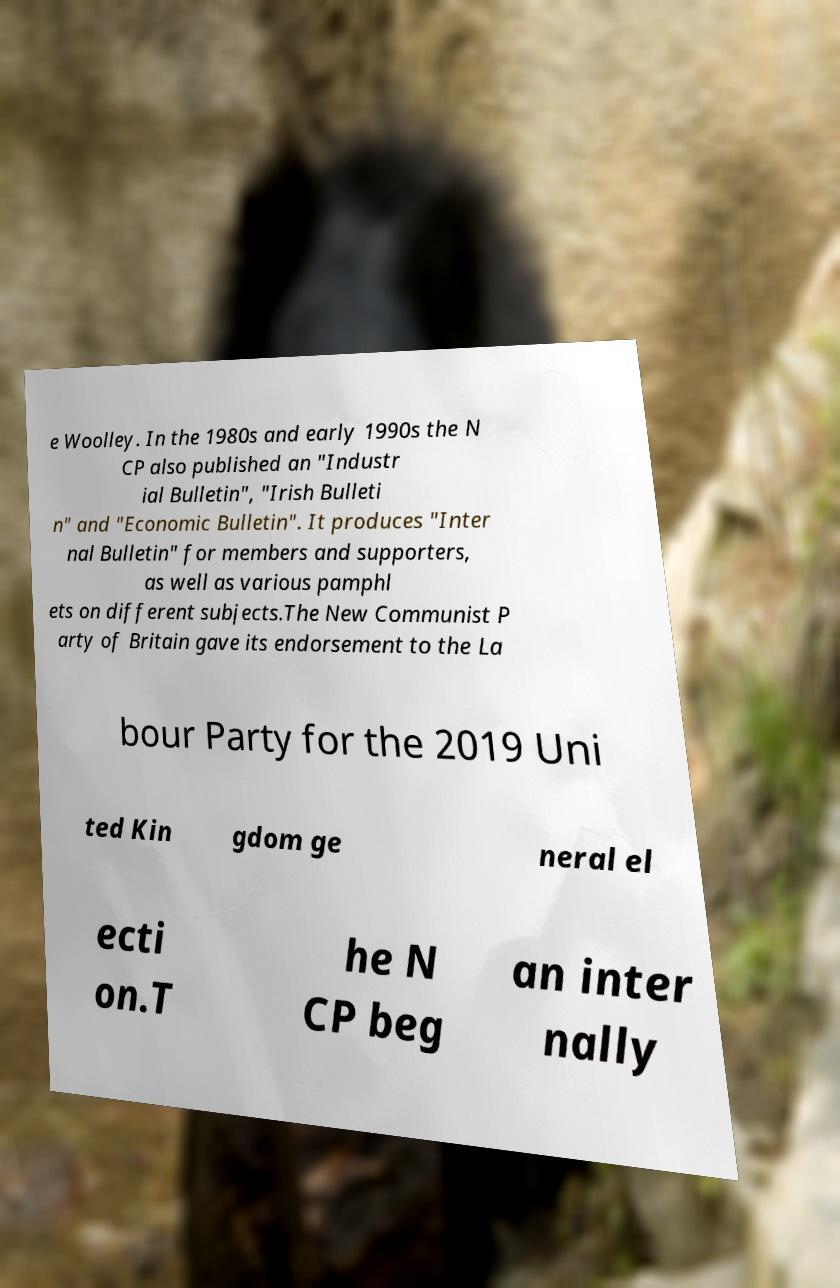There's text embedded in this image that I need extracted. Can you transcribe it verbatim? e Woolley. In the 1980s and early 1990s the N CP also published an "Industr ial Bulletin", "Irish Bulleti n" and "Economic Bulletin". It produces "Inter nal Bulletin" for members and supporters, as well as various pamphl ets on different subjects.The New Communist P arty of Britain gave its endorsement to the La bour Party for the 2019 Uni ted Kin gdom ge neral el ecti on.T he N CP beg an inter nally 